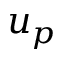<formula> <loc_0><loc_0><loc_500><loc_500>u _ { p }</formula> 